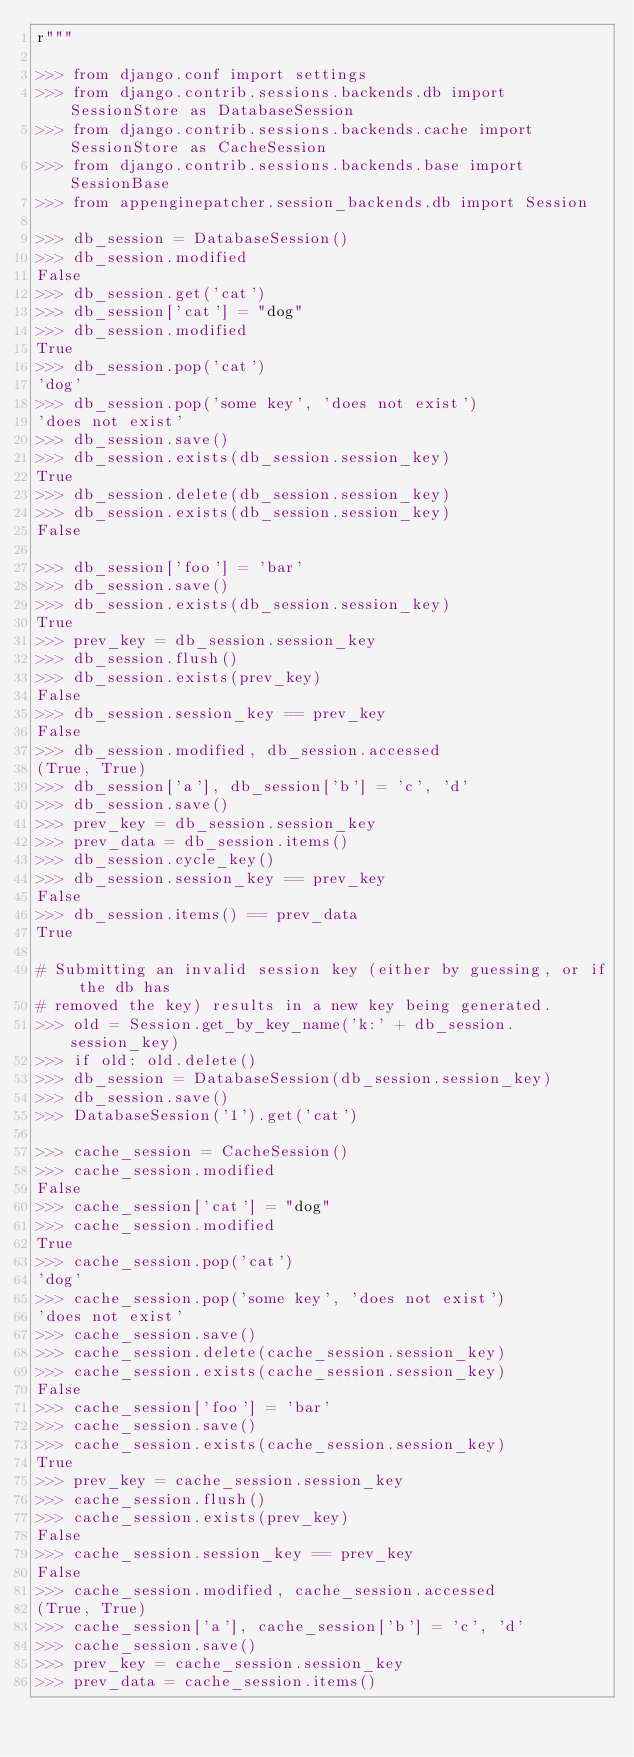<code> <loc_0><loc_0><loc_500><loc_500><_Python_>r"""

>>> from django.conf import settings
>>> from django.contrib.sessions.backends.db import SessionStore as DatabaseSession
>>> from django.contrib.sessions.backends.cache import SessionStore as CacheSession
>>> from django.contrib.sessions.backends.base import SessionBase
>>> from appenginepatcher.session_backends.db import Session

>>> db_session = DatabaseSession()
>>> db_session.modified
False
>>> db_session.get('cat')
>>> db_session['cat'] = "dog"
>>> db_session.modified
True
>>> db_session.pop('cat')
'dog'
>>> db_session.pop('some key', 'does not exist')
'does not exist'
>>> db_session.save()
>>> db_session.exists(db_session.session_key)
True
>>> db_session.delete(db_session.session_key)
>>> db_session.exists(db_session.session_key)
False

>>> db_session['foo'] = 'bar'
>>> db_session.save()
>>> db_session.exists(db_session.session_key)
True
>>> prev_key = db_session.session_key
>>> db_session.flush()
>>> db_session.exists(prev_key)
False
>>> db_session.session_key == prev_key
False
>>> db_session.modified, db_session.accessed
(True, True)
>>> db_session['a'], db_session['b'] = 'c', 'd'
>>> db_session.save()
>>> prev_key = db_session.session_key
>>> prev_data = db_session.items()
>>> db_session.cycle_key()
>>> db_session.session_key == prev_key
False
>>> db_session.items() == prev_data
True

# Submitting an invalid session key (either by guessing, or if the db has
# removed the key) results in a new key being generated.
>>> old = Session.get_by_key_name('k:' + db_session.session_key)
>>> if old: old.delete()
>>> db_session = DatabaseSession(db_session.session_key)
>>> db_session.save()
>>> DatabaseSession('1').get('cat')

>>> cache_session = CacheSession()
>>> cache_session.modified
False
>>> cache_session['cat'] = "dog"
>>> cache_session.modified
True
>>> cache_session.pop('cat')
'dog'
>>> cache_session.pop('some key', 'does not exist')
'does not exist'
>>> cache_session.save()
>>> cache_session.delete(cache_session.session_key)
>>> cache_session.exists(cache_session.session_key)
False
>>> cache_session['foo'] = 'bar'
>>> cache_session.save()
>>> cache_session.exists(cache_session.session_key)
True
>>> prev_key = cache_session.session_key
>>> cache_session.flush()
>>> cache_session.exists(prev_key)
False
>>> cache_session.session_key == prev_key
False
>>> cache_session.modified, cache_session.accessed
(True, True)
>>> cache_session['a'], cache_session['b'] = 'c', 'd'
>>> cache_session.save()
>>> prev_key = cache_session.session_key
>>> prev_data = cache_session.items()</code> 